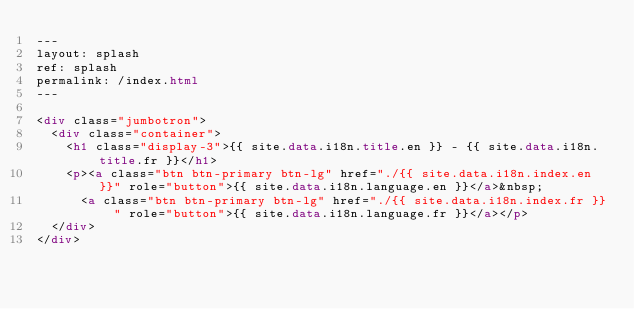<code> <loc_0><loc_0><loc_500><loc_500><_HTML_>---
layout: splash
ref: splash
permalink: /index.html
---

<div class="jumbotron">
  <div class="container">
    <h1 class="display-3">{{ site.data.i18n.title.en }} - {{ site.data.i18n.title.fr }}</h1>
    <p><a class="btn btn-primary btn-lg" href="./{{ site.data.i18n.index.en }}" role="button">{{ site.data.i18n.language.en }}</a>&nbsp;
      <a class="btn btn-primary btn-lg" href="./{{ site.data.i18n.index.fr }}" role="button">{{ site.data.i18n.language.fr }}</a></p>
  </div>
</div>
</code> 